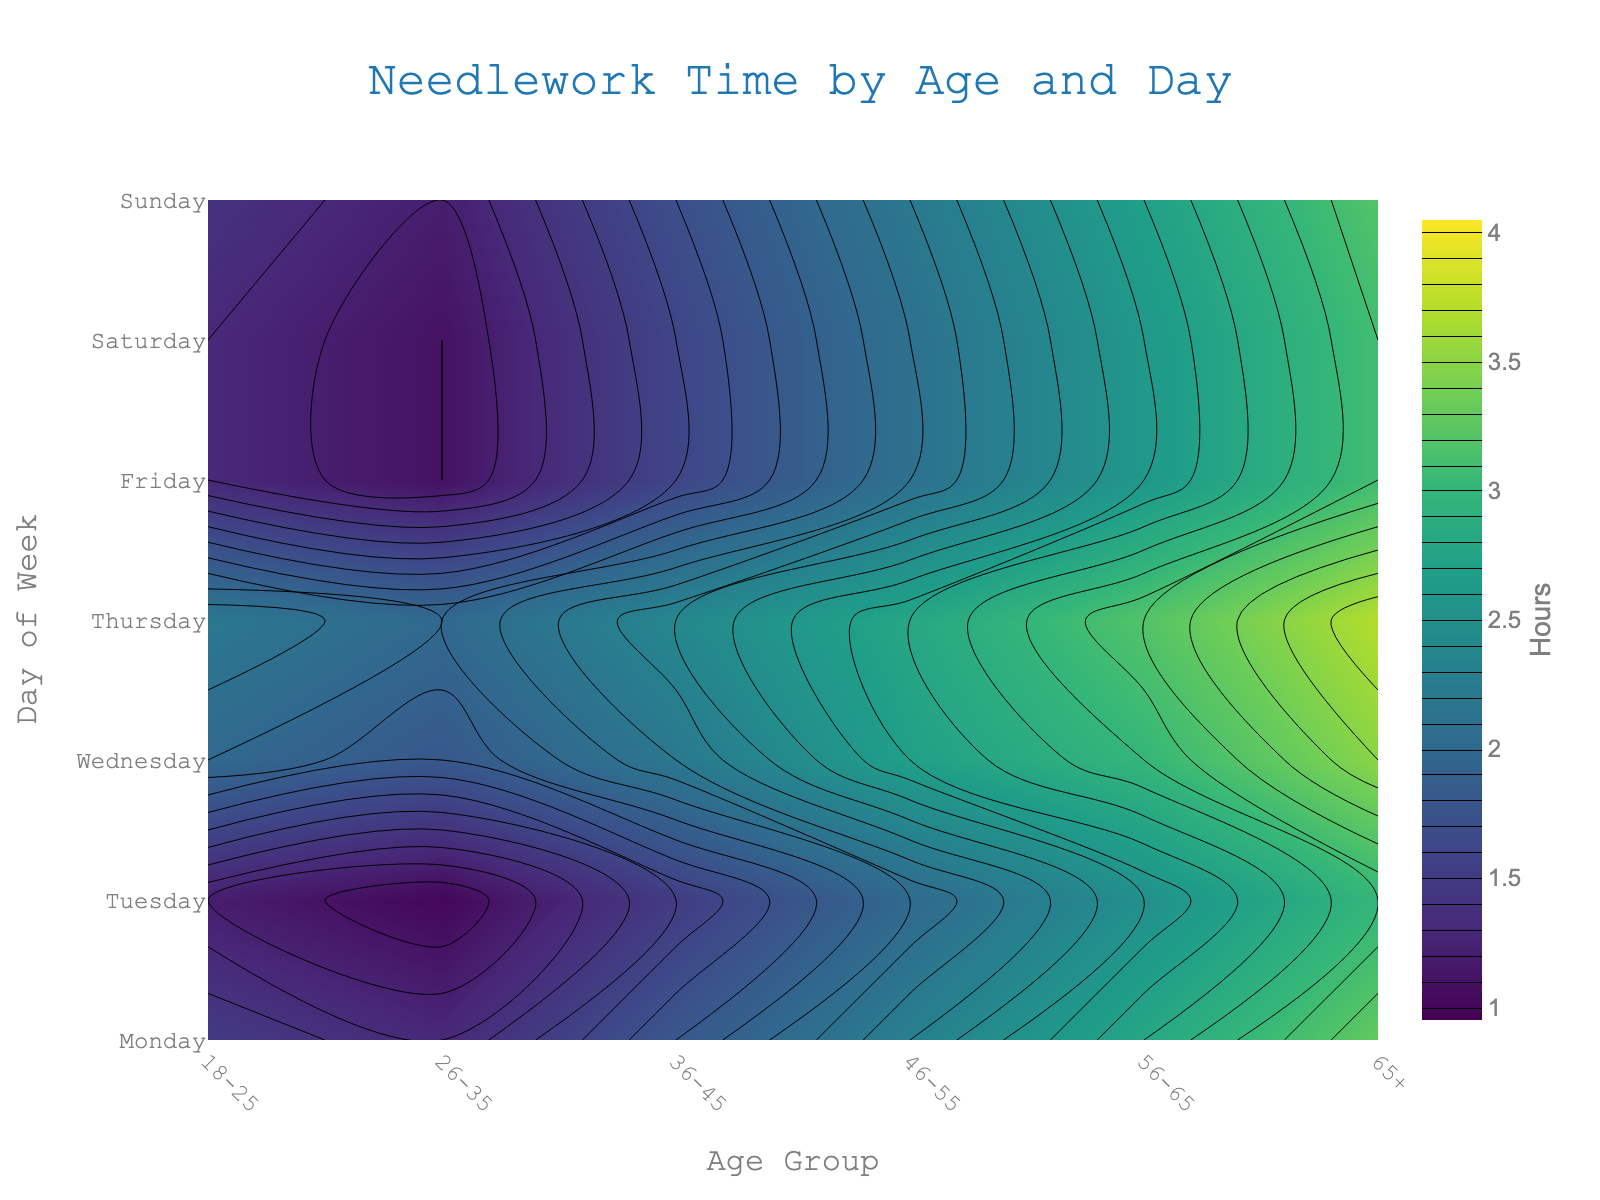What is the title of the plot? The title of the plot is typically presented at the top of the figure. In this case, it should summarize what the plot represents. Look at the text centered at the top.
Answer: Needlework Time by Age and Day Which age group spends the most time on needlework on Saturdays? To find the age group that spends the most time, look along the "Saturday" row and identify the highest value. Then, match this value to the corresponding age group.
Answer: 65+ What is the time spent on needlework by the 36-45 age group on Mondays? Find the column labeled "36-45" and then look at the value in the row labeled "Monday". This value represents the time spent.
Answer: 1.5 hours How does the needlework time trend, from Monday to Sunday, for the 65+ age group? To identify this trend, look at the column for "65+" and observe how the values change from "Monday" down to "Sunday". Describe whether the trend is increasing, decreasing, or remains constant.
Answer: Increasing On which day does the 18-25 age group spend the least time on needlework? To answer this, observe the row values for "18-25" and find the smallest value. Then, note the corresponding day of the week.
Answer: Monday What is the difference in time spent on needlework between the 56-65 and 65+ age groups on Sundays? Compare the values for the "56-65" and "65+" age groups on the "Sunday" row and subtract the smaller value from the larger value.
Answer: 0.5 hours Which day shows the smallest variation in needlework time across all age groups? To determine this, you need to inspect the values for each day and calculate the variation (range) for each day. The day with the smallest range would be the answer.
Answer: Tuesday Compare the needlework time for the 26-35 age group between Wednesday and Friday. Which day exhibits higher needlework time and by how much? Look at the "26-35" column and compare the values for "Wednesday" and "Friday". Subtract the smaller value from the larger one to find the difference.
Answer: Friday; 0.1 hours How much more time does the 65+ age group spend on needlework on Sundays compared to Thursdays? Identify the values for the "65+" age group on "Sunday" and "Thursday". Subtract the value for "Thursday" from that for "Sunday".
Answer: 0.6 hours Overall, which day has the highest average needlework time across all age groups? To find this, calculate the average of needlework times for each day by summing the values in each row and dividing by the number of values (age groups). Compare these averages and determine the highest.
Answer: Sunday 